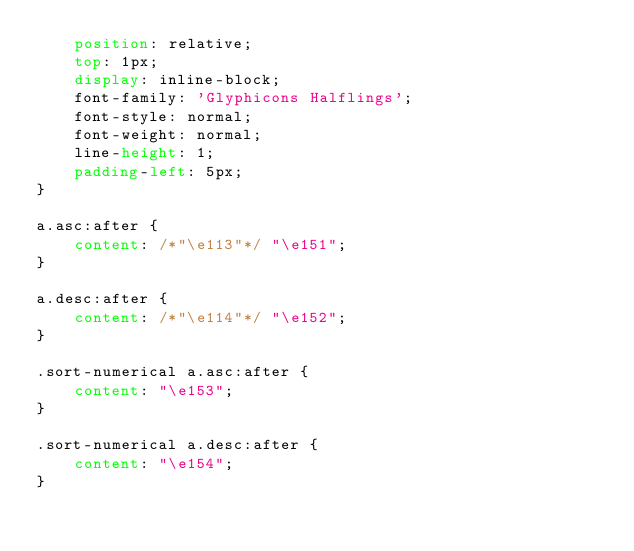<code> <loc_0><loc_0><loc_500><loc_500><_CSS_>    position: relative;
    top: 1px;
    display: inline-block;
    font-family: 'Glyphicons Halflings';
    font-style: normal;
    font-weight: normal;
    line-height: 1;
    padding-left: 5px;
}

a.asc:after {
    content: /*"\e113"*/ "\e151";
}

a.desc:after {
    content: /*"\e114"*/ "\e152";
}

.sort-numerical a.asc:after {
    content: "\e153";
}

.sort-numerical a.desc:after {
    content: "\e154";
}
</code> 